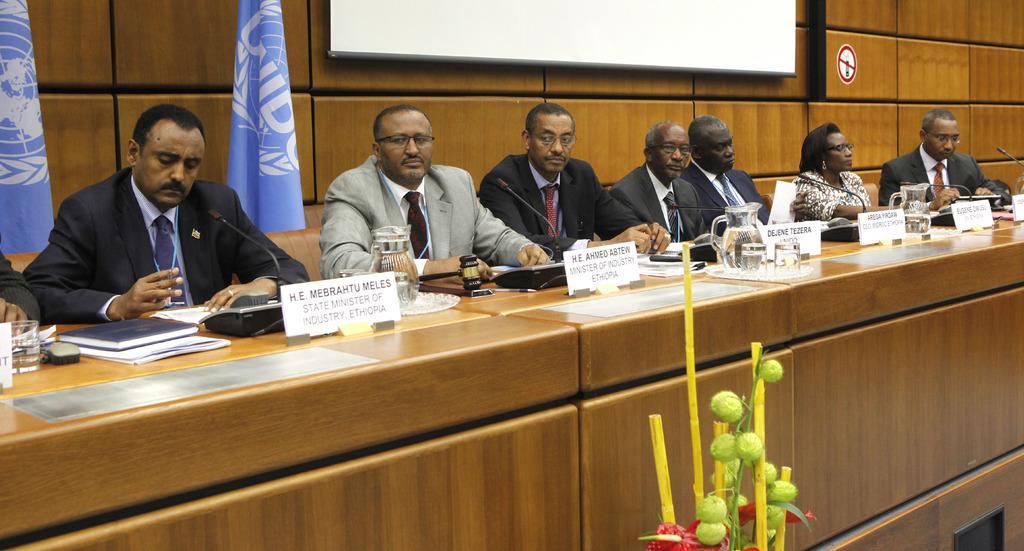Describe this image in one or two sentences. There are people those who are sitting in the center of the image in front of a wooden desk there are books, telephones, glasses, papers and name plates on the desk, there are flags, screw, and a sign sticker in the background area, it seems like a plant at the bottom side. 